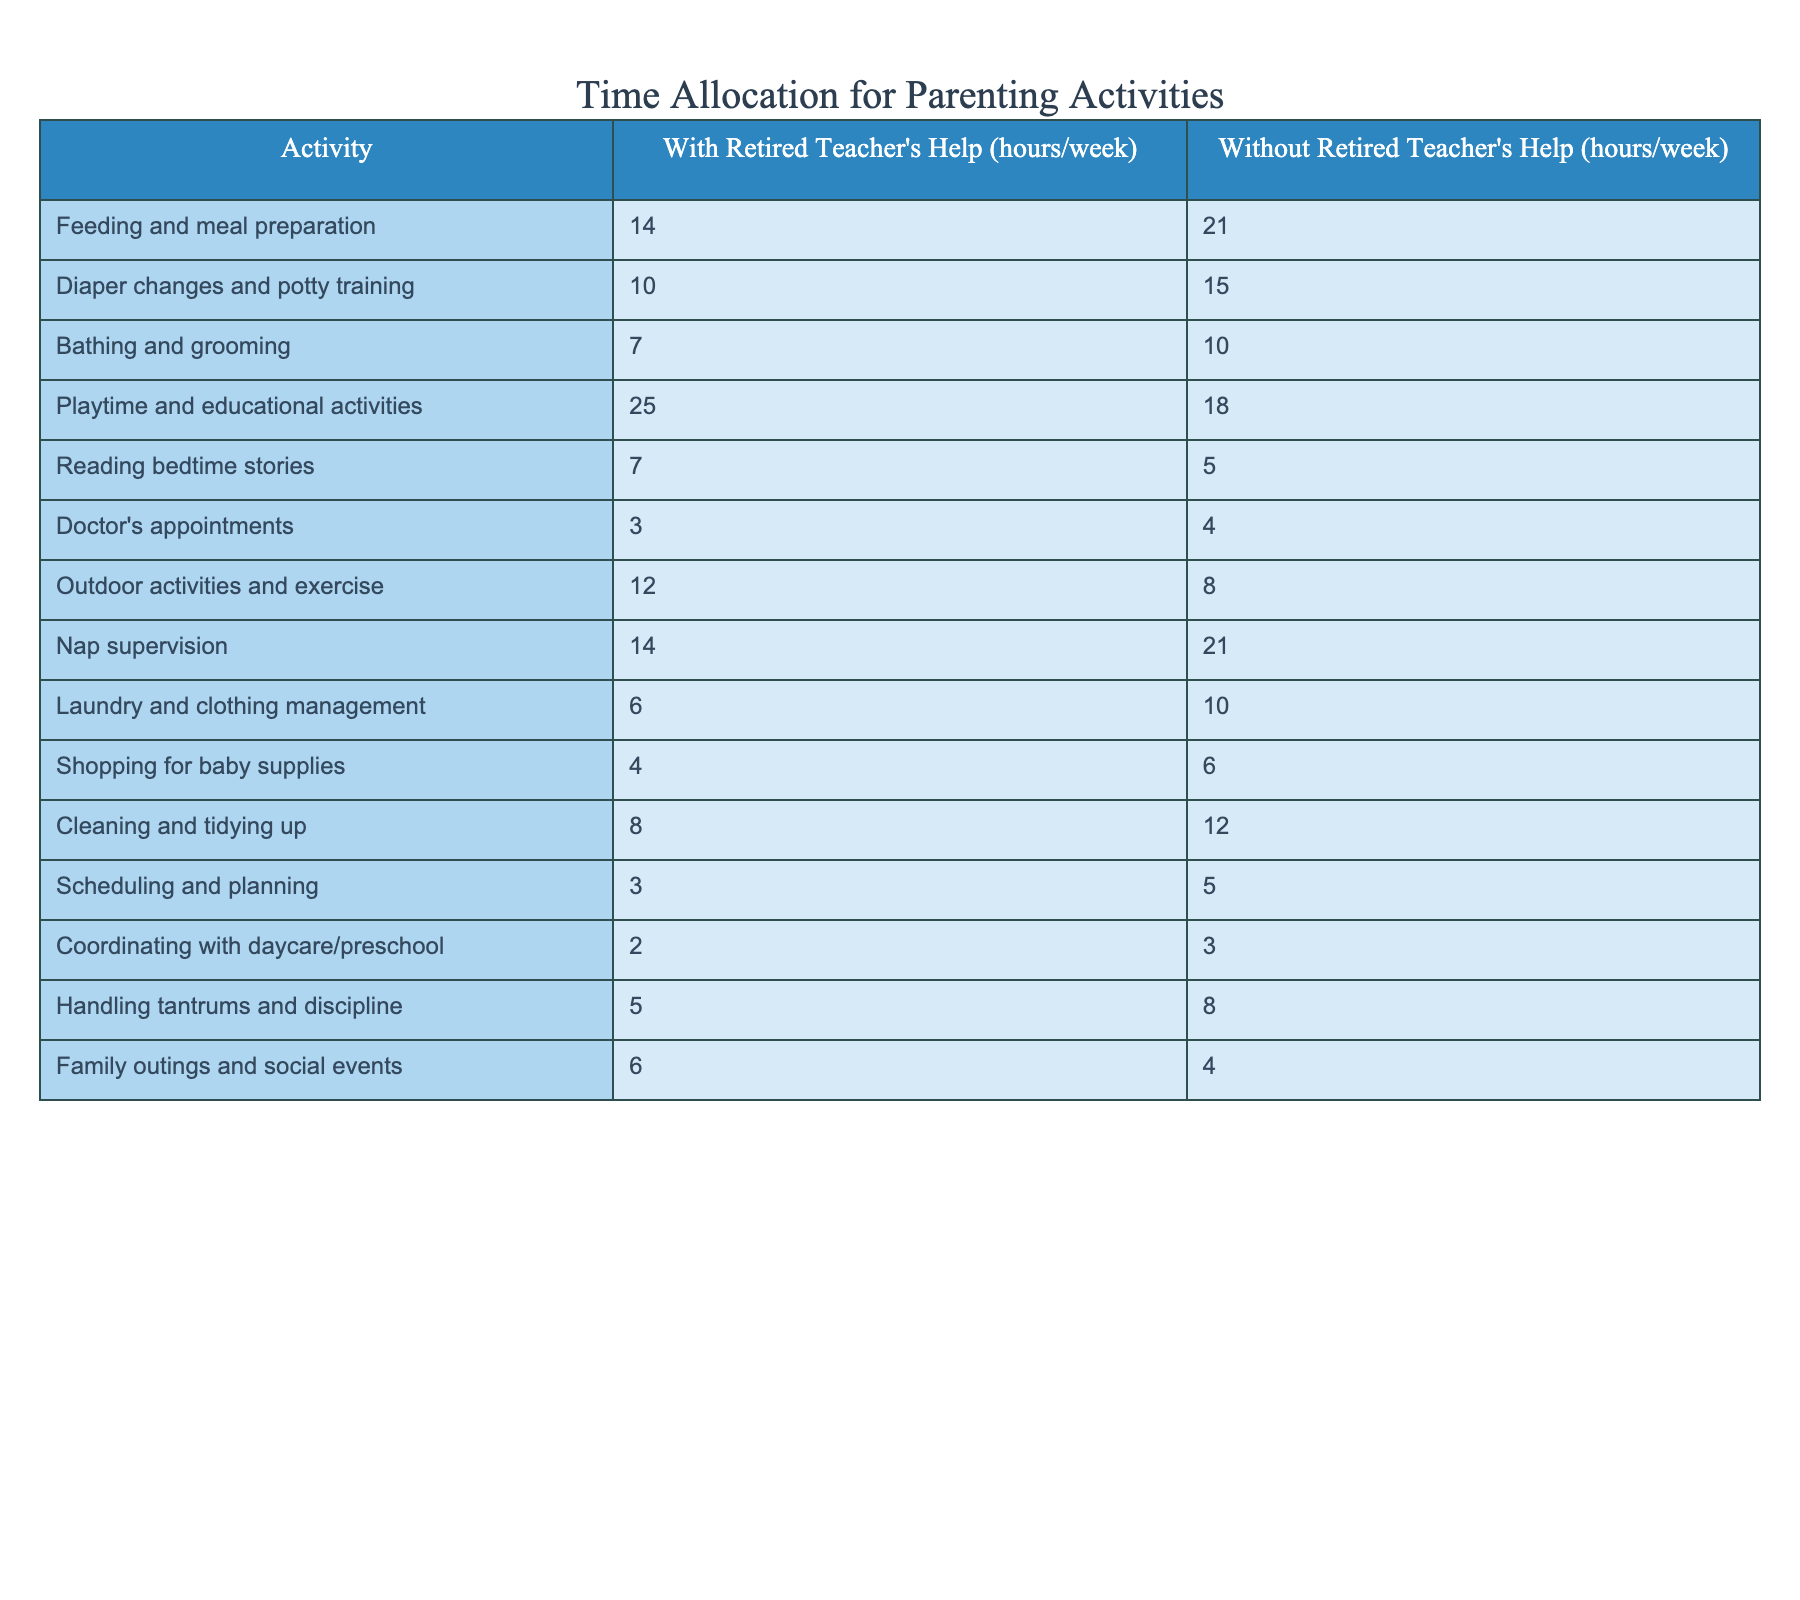What is the total time spent on feeding and meal preparation with retired teacher's help? From the table, the value for feeding and meal preparation with retired teacher's help is 14 hours/week. There are no further calculations needed since we are looking for a specific value.
Answer: 14 hours How much more time is spent on diaper changes and potty training without help compared to with help? The time spent on diaper changes and potty training with help is 10 hours/week and without help is 15 hours/week. To find the difference, subtract the time with help from the time without help: 15 - 10 = 5 hours.
Answer: 5 hours Is more time spent on playtime and educational activities with the retired teacher's help or without? The table shows 25 hours/week when the retired teacher helps and 18 hours/week without help. Since 25 is greater than 18, more time is spent with the teacher's help.
Answer: Yes What is the combined total time for laundry and cleaning with the retired teacher's help? The time for laundry is 6 hours/week and for cleaning is 8 hours/week with help. To find the combined total, sum the two values: 6 + 8 = 14 hours.
Answer: 14 hours What percentage reduction in hours spent on outdoor activities and exercise is there with the retired teacher's help compared to without help? The time spent without help is 12 hours/week, and with help, it’s 8 hours/week. The reduction is 12 - 8 = 4 hours. To find the percentage reduction, calculate (4/12) * 100 = 33.33%.
Answer: 33.33% How many total hours per week are allocated to reading bedtime stories and coordinating with daycare when the retired teacher is present? The table indicates 7 hours for reading bedtime stories and 2 hours for coordinating with daycare. To find the total hours, add the two values: 7 + 2 = 9 hours.
Answer: 9 hours Are more hours spent on handling tantrums and discipline with or without help? The table shows 5 hours with the retired teacher's help and 8 hours without help. Comparing the two shows that more hours are spent without help, as 8 is greater than 5.
Answer: Yes What is the difference in hours allocated to scheduling and planning with and without the retired teacher's help? The time for scheduling and planning is 3 hours with help and 5 hours without help. The difference is obtained by subtracting the two values: 5 - 3 = 2 hours.
Answer: 2 hours In total, how many hours are spent on diaper changes, bathing, and grooming with the help of the retired teacher? The hours spent with help are: 10 for diaper changes and 7 for bathing and grooming. Summing these gives: 10 + 7 = 17 hours.
Answer: 17 hours 